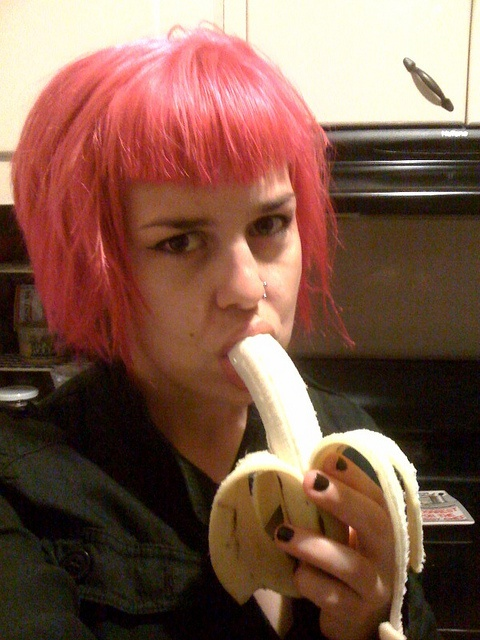Describe the objects in this image and their specific colors. I can see people in white, black, maroon, and brown tones and banana in white, ivory, maroon, and olive tones in this image. 